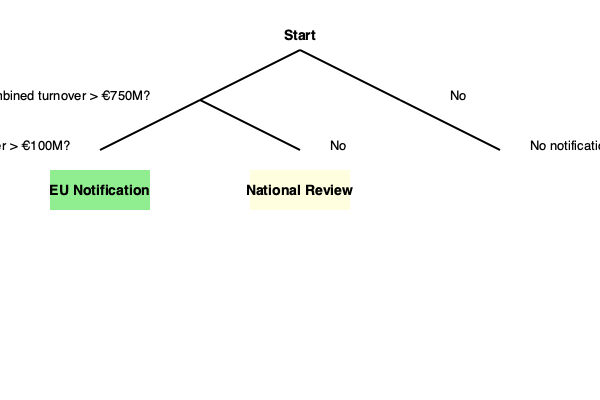Based on the merger control threshold decision tree diagram, under what circumstances would a merger require EU notification? To determine whether a merger requires EU notification, we need to follow the decision tree:

1. Start at the top of the tree.

2. The first decision point asks if the combined turnover of the merging entities is greater than €750 million.
   - If no, follow the right branch, which leads to "No notification required".
   - If yes, proceed to the next decision point on the left branch.

3. The second decision point asks if the EU-wide turnover is greater than €100 million.
   - If no, follow the right branch to "National Review".
   - If yes, follow the left branch to "EU Notification".

Therefore, for a merger to require EU notification, it must meet two criteria:
a) The combined turnover of the merging entities must exceed €750 million, AND
b) The EU-wide turnover must exceed €100 million.

These thresholds are designed to capture mergers that have a significant impact on the EU market, warranting review at the EU level rather than by individual member states.
Answer: Combined turnover > €750M AND EU-wide turnover > €100M 